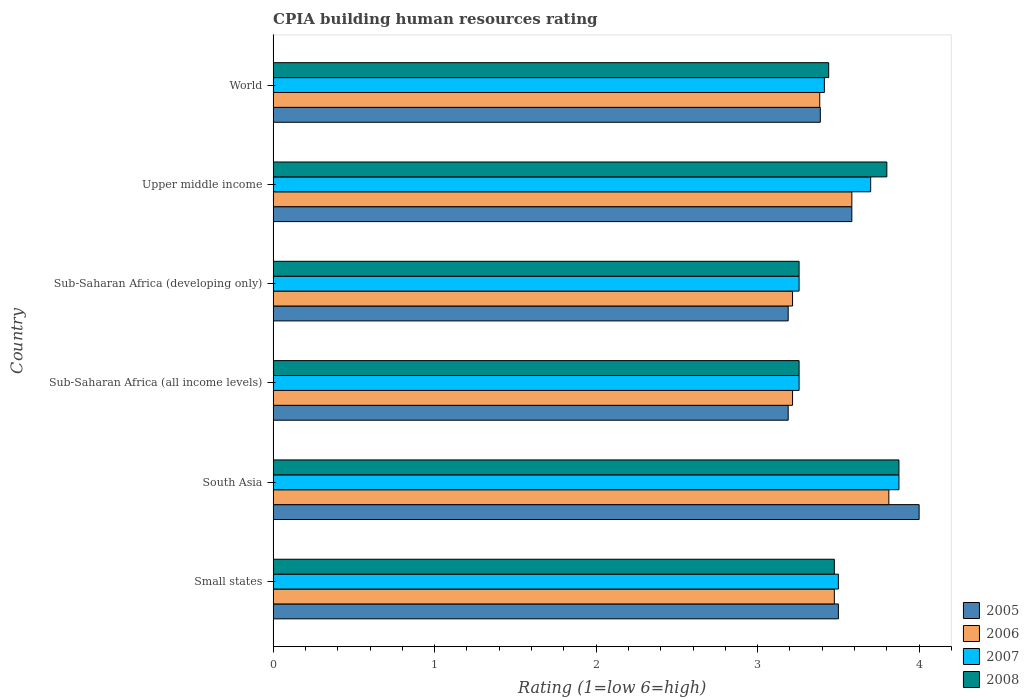How many groups of bars are there?
Your answer should be compact. 6. Are the number of bars per tick equal to the number of legend labels?
Your response must be concise. Yes. Are the number of bars on each tick of the Y-axis equal?
Provide a short and direct response. Yes. How many bars are there on the 6th tick from the bottom?
Your response must be concise. 4. What is the label of the 6th group of bars from the top?
Give a very brief answer. Small states. In how many cases, is the number of bars for a given country not equal to the number of legend labels?
Keep it short and to the point. 0. What is the CPIA rating in 2007 in World?
Keep it short and to the point. 3.41. Across all countries, what is the maximum CPIA rating in 2005?
Provide a short and direct response. 4. Across all countries, what is the minimum CPIA rating in 2005?
Ensure brevity in your answer.  3.19. In which country was the CPIA rating in 2008 maximum?
Offer a terse response. South Asia. In which country was the CPIA rating in 2006 minimum?
Ensure brevity in your answer.  Sub-Saharan Africa (all income levels). What is the total CPIA rating in 2005 in the graph?
Give a very brief answer. 20.85. What is the difference between the CPIA rating in 2005 in Small states and that in World?
Provide a short and direct response. 0.11. What is the difference between the CPIA rating in 2007 in Small states and the CPIA rating in 2008 in Upper middle income?
Your answer should be compact. -0.3. What is the average CPIA rating in 2008 per country?
Offer a terse response. 3.52. What is the difference between the CPIA rating in 2007 and CPIA rating in 2006 in Small states?
Ensure brevity in your answer.  0.02. What is the ratio of the CPIA rating in 2005 in South Asia to that in Sub-Saharan Africa (developing only)?
Provide a succinct answer. 1.25. Is the CPIA rating in 2006 in Small states less than that in Sub-Saharan Africa (all income levels)?
Give a very brief answer. No. Is the difference between the CPIA rating in 2007 in Sub-Saharan Africa (all income levels) and Sub-Saharan Africa (developing only) greater than the difference between the CPIA rating in 2006 in Sub-Saharan Africa (all income levels) and Sub-Saharan Africa (developing only)?
Your answer should be very brief. No. What is the difference between the highest and the second highest CPIA rating in 2006?
Provide a succinct answer. 0.23. What is the difference between the highest and the lowest CPIA rating in 2006?
Your answer should be compact. 0.6. In how many countries, is the CPIA rating in 2007 greater than the average CPIA rating in 2007 taken over all countries?
Your answer should be very brief. 2. Is the sum of the CPIA rating in 2007 in Upper middle income and World greater than the maximum CPIA rating in 2005 across all countries?
Keep it short and to the point. Yes. Is it the case that in every country, the sum of the CPIA rating in 2008 and CPIA rating in 2005 is greater than the sum of CPIA rating in 2007 and CPIA rating in 2006?
Your response must be concise. Yes. What does the 2nd bar from the top in Sub-Saharan Africa (developing only) represents?
Keep it short and to the point. 2007. Are all the bars in the graph horizontal?
Keep it short and to the point. Yes. How many countries are there in the graph?
Ensure brevity in your answer.  6. What is the difference between two consecutive major ticks on the X-axis?
Offer a very short reply. 1. Does the graph contain grids?
Your answer should be compact. No. How are the legend labels stacked?
Give a very brief answer. Vertical. What is the title of the graph?
Ensure brevity in your answer.  CPIA building human resources rating. What is the label or title of the X-axis?
Offer a terse response. Rating (1=low 6=high). What is the label or title of the Y-axis?
Provide a succinct answer. Country. What is the Rating (1=low 6=high) of 2006 in Small states?
Your response must be concise. 3.48. What is the Rating (1=low 6=high) of 2007 in Small states?
Provide a short and direct response. 3.5. What is the Rating (1=low 6=high) of 2008 in Small states?
Offer a very short reply. 3.48. What is the Rating (1=low 6=high) of 2005 in South Asia?
Offer a terse response. 4. What is the Rating (1=low 6=high) of 2006 in South Asia?
Your response must be concise. 3.81. What is the Rating (1=low 6=high) in 2007 in South Asia?
Your answer should be compact. 3.88. What is the Rating (1=low 6=high) of 2008 in South Asia?
Make the answer very short. 3.88. What is the Rating (1=low 6=high) of 2005 in Sub-Saharan Africa (all income levels)?
Offer a terse response. 3.19. What is the Rating (1=low 6=high) in 2006 in Sub-Saharan Africa (all income levels)?
Your response must be concise. 3.22. What is the Rating (1=low 6=high) of 2007 in Sub-Saharan Africa (all income levels)?
Ensure brevity in your answer.  3.26. What is the Rating (1=low 6=high) in 2008 in Sub-Saharan Africa (all income levels)?
Your response must be concise. 3.26. What is the Rating (1=low 6=high) in 2005 in Sub-Saharan Africa (developing only)?
Your answer should be compact. 3.19. What is the Rating (1=low 6=high) of 2006 in Sub-Saharan Africa (developing only)?
Give a very brief answer. 3.22. What is the Rating (1=low 6=high) in 2007 in Sub-Saharan Africa (developing only)?
Ensure brevity in your answer.  3.26. What is the Rating (1=low 6=high) of 2008 in Sub-Saharan Africa (developing only)?
Offer a terse response. 3.26. What is the Rating (1=low 6=high) in 2005 in Upper middle income?
Your answer should be very brief. 3.58. What is the Rating (1=low 6=high) in 2006 in Upper middle income?
Provide a short and direct response. 3.58. What is the Rating (1=low 6=high) of 2005 in World?
Ensure brevity in your answer.  3.39. What is the Rating (1=low 6=high) of 2006 in World?
Provide a short and direct response. 3.38. What is the Rating (1=low 6=high) in 2007 in World?
Provide a succinct answer. 3.41. What is the Rating (1=low 6=high) of 2008 in World?
Keep it short and to the point. 3.44. Across all countries, what is the maximum Rating (1=low 6=high) in 2005?
Your answer should be very brief. 4. Across all countries, what is the maximum Rating (1=low 6=high) in 2006?
Offer a very short reply. 3.81. Across all countries, what is the maximum Rating (1=low 6=high) in 2007?
Ensure brevity in your answer.  3.88. Across all countries, what is the maximum Rating (1=low 6=high) in 2008?
Ensure brevity in your answer.  3.88. Across all countries, what is the minimum Rating (1=low 6=high) of 2005?
Offer a terse response. 3.19. Across all countries, what is the minimum Rating (1=low 6=high) in 2006?
Your answer should be very brief. 3.22. Across all countries, what is the minimum Rating (1=low 6=high) in 2007?
Your answer should be compact. 3.26. Across all countries, what is the minimum Rating (1=low 6=high) of 2008?
Your answer should be very brief. 3.26. What is the total Rating (1=low 6=high) of 2005 in the graph?
Keep it short and to the point. 20.85. What is the total Rating (1=low 6=high) of 2006 in the graph?
Offer a very short reply. 20.69. What is the total Rating (1=low 6=high) in 2007 in the graph?
Make the answer very short. 21. What is the total Rating (1=low 6=high) of 2008 in the graph?
Offer a very short reply. 21.1. What is the difference between the Rating (1=low 6=high) of 2006 in Small states and that in South Asia?
Your answer should be compact. -0.34. What is the difference between the Rating (1=low 6=high) in 2007 in Small states and that in South Asia?
Offer a very short reply. -0.38. What is the difference between the Rating (1=low 6=high) of 2005 in Small states and that in Sub-Saharan Africa (all income levels)?
Provide a short and direct response. 0.31. What is the difference between the Rating (1=low 6=high) in 2006 in Small states and that in Sub-Saharan Africa (all income levels)?
Your answer should be very brief. 0.26. What is the difference between the Rating (1=low 6=high) in 2007 in Small states and that in Sub-Saharan Africa (all income levels)?
Ensure brevity in your answer.  0.24. What is the difference between the Rating (1=low 6=high) in 2008 in Small states and that in Sub-Saharan Africa (all income levels)?
Your answer should be compact. 0.22. What is the difference between the Rating (1=low 6=high) in 2005 in Small states and that in Sub-Saharan Africa (developing only)?
Offer a very short reply. 0.31. What is the difference between the Rating (1=low 6=high) in 2006 in Small states and that in Sub-Saharan Africa (developing only)?
Offer a very short reply. 0.26. What is the difference between the Rating (1=low 6=high) of 2007 in Small states and that in Sub-Saharan Africa (developing only)?
Your response must be concise. 0.24. What is the difference between the Rating (1=low 6=high) of 2008 in Small states and that in Sub-Saharan Africa (developing only)?
Offer a terse response. 0.22. What is the difference between the Rating (1=low 6=high) in 2005 in Small states and that in Upper middle income?
Your answer should be very brief. -0.08. What is the difference between the Rating (1=low 6=high) of 2006 in Small states and that in Upper middle income?
Offer a very short reply. -0.11. What is the difference between the Rating (1=low 6=high) of 2008 in Small states and that in Upper middle income?
Offer a terse response. -0.33. What is the difference between the Rating (1=low 6=high) of 2005 in Small states and that in World?
Your response must be concise. 0.11. What is the difference between the Rating (1=low 6=high) of 2006 in Small states and that in World?
Provide a succinct answer. 0.09. What is the difference between the Rating (1=low 6=high) in 2007 in Small states and that in World?
Ensure brevity in your answer.  0.09. What is the difference between the Rating (1=low 6=high) in 2008 in Small states and that in World?
Offer a very short reply. 0.04. What is the difference between the Rating (1=low 6=high) of 2005 in South Asia and that in Sub-Saharan Africa (all income levels)?
Keep it short and to the point. 0.81. What is the difference between the Rating (1=low 6=high) of 2006 in South Asia and that in Sub-Saharan Africa (all income levels)?
Give a very brief answer. 0.6. What is the difference between the Rating (1=low 6=high) in 2007 in South Asia and that in Sub-Saharan Africa (all income levels)?
Your answer should be compact. 0.62. What is the difference between the Rating (1=low 6=high) of 2008 in South Asia and that in Sub-Saharan Africa (all income levels)?
Keep it short and to the point. 0.62. What is the difference between the Rating (1=low 6=high) in 2005 in South Asia and that in Sub-Saharan Africa (developing only)?
Your response must be concise. 0.81. What is the difference between the Rating (1=low 6=high) in 2006 in South Asia and that in Sub-Saharan Africa (developing only)?
Your response must be concise. 0.6. What is the difference between the Rating (1=low 6=high) of 2007 in South Asia and that in Sub-Saharan Africa (developing only)?
Provide a succinct answer. 0.62. What is the difference between the Rating (1=low 6=high) in 2008 in South Asia and that in Sub-Saharan Africa (developing only)?
Make the answer very short. 0.62. What is the difference between the Rating (1=low 6=high) in 2005 in South Asia and that in Upper middle income?
Your answer should be compact. 0.42. What is the difference between the Rating (1=low 6=high) of 2006 in South Asia and that in Upper middle income?
Ensure brevity in your answer.  0.23. What is the difference between the Rating (1=low 6=high) of 2007 in South Asia and that in Upper middle income?
Keep it short and to the point. 0.17. What is the difference between the Rating (1=low 6=high) of 2008 in South Asia and that in Upper middle income?
Make the answer very short. 0.07. What is the difference between the Rating (1=low 6=high) of 2005 in South Asia and that in World?
Offer a terse response. 0.61. What is the difference between the Rating (1=low 6=high) of 2006 in South Asia and that in World?
Provide a short and direct response. 0.43. What is the difference between the Rating (1=low 6=high) in 2007 in South Asia and that in World?
Your response must be concise. 0.46. What is the difference between the Rating (1=low 6=high) of 2008 in South Asia and that in World?
Your answer should be compact. 0.43. What is the difference between the Rating (1=low 6=high) in 2005 in Sub-Saharan Africa (all income levels) and that in Sub-Saharan Africa (developing only)?
Provide a succinct answer. 0. What is the difference between the Rating (1=low 6=high) of 2006 in Sub-Saharan Africa (all income levels) and that in Sub-Saharan Africa (developing only)?
Provide a short and direct response. 0. What is the difference between the Rating (1=low 6=high) in 2007 in Sub-Saharan Africa (all income levels) and that in Sub-Saharan Africa (developing only)?
Your response must be concise. 0. What is the difference between the Rating (1=low 6=high) in 2005 in Sub-Saharan Africa (all income levels) and that in Upper middle income?
Give a very brief answer. -0.39. What is the difference between the Rating (1=low 6=high) in 2006 in Sub-Saharan Africa (all income levels) and that in Upper middle income?
Ensure brevity in your answer.  -0.37. What is the difference between the Rating (1=low 6=high) in 2007 in Sub-Saharan Africa (all income levels) and that in Upper middle income?
Give a very brief answer. -0.44. What is the difference between the Rating (1=low 6=high) of 2008 in Sub-Saharan Africa (all income levels) and that in Upper middle income?
Offer a terse response. -0.54. What is the difference between the Rating (1=low 6=high) of 2005 in Sub-Saharan Africa (all income levels) and that in World?
Provide a succinct answer. -0.2. What is the difference between the Rating (1=low 6=high) of 2006 in Sub-Saharan Africa (all income levels) and that in World?
Provide a short and direct response. -0.17. What is the difference between the Rating (1=low 6=high) of 2007 in Sub-Saharan Africa (all income levels) and that in World?
Your answer should be compact. -0.16. What is the difference between the Rating (1=low 6=high) in 2008 in Sub-Saharan Africa (all income levels) and that in World?
Give a very brief answer. -0.18. What is the difference between the Rating (1=low 6=high) of 2005 in Sub-Saharan Africa (developing only) and that in Upper middle income?
Offer a terse response. -0.39. What is the difference between the Rating (1=low 6=high) of 2006 in Sub-Saharan Africa (developing only) and that in Upper middle income?
Your answer should be compact. -0.37. What is the difference between the Rating (1=low 6=high) in 2007 in Sub-Saharan Africa (developing only) and that in Upper middle income?
Provide a short and direct response. -0.44. What is the difference between the Rating (1=low 6=high) in 2008 in Sub-Saharan Africa (developing only) and that in Upper middle income?
Your answer should be very brief. -0.54. What is the difference between the Rating (1=low 6=high) in 2005 in Sub-Saharan Africa (developing only) and that in World?
Provide a short and direct response. -0.2. What is the difference between the Rating (1=low 6=high) of 2006 in Sub-Saharan Africa (developing only) and that in World?
Your response must be concise. -0.17. What is the difference between the Rating (1=low 6=high) of 2007 in Sub-Saharan Africa (developing only) and that in World?
Offer a terse response. -0.16. What is the difference between the Rating (1=low 6=high) of 2008 in Sub-Saharan Africa (developing only) and that in World?
Ensure brevity in your answer.  -0.18. What is the difference between the Rating (1=low 6=high) in 2005 in Upper middle income and that in World?
Give a very brief answer. 0.2. What is the difference between the Rating (1=low 6=high) in 2006 in Upper middle income and that in World?
Make the answer very short. 0.2. What is the difference between the Rating (1=low 6=high) of 2007 in Upper middle income and that in World?
Offer a very short reply. 0.29. What is the difference between the Rating (1=low 6=high) in 2008 in Upper middle income and that in World?
Ensure brevity in your answer.  0.36. What is the difference between the Rating (1=low 6=high) of 2005 in Small states and the Rating (1=low 6=high) of 2006 in South Asia?
Offer a terse response. -0.31. What is the difference between the Rating (1=low 6=high) in 2005 in Small states and the Rating (1=low 6=high) in 2007 in South Asia?
Offer a terse response. -0.38. What is the difference between the Rating (1=low 6=high) in 2005 in Small states and the Rating (1=low 6=high) in 2008 in South Asia?
Ensure brevity in your answer.  -0.38. What is the difference between the Rating (1=low 6=high) of 2006 in Small states and the Rating (1=low 6=high) of 2007 in South Asia?
Offer a very short reply. -0.4. What is the difference between the Rating (1=low 6=high) of 2006 in Small states and the Rating (1=low 6=high) of 2008 in South Asia?
Provide a short and direct response. -0.4. What is the difference between the Rating (1=low 6=high) in 2007 in Small states and the Rating (1=low 6=high) in 2008 in South Asia?
Keep it short and to the point. -0.38. What is the difference between the Rating (1=low 6=high) in 2005 in Small states and the Rating (1=low 6=high) in 2006 in Sub-Saharan Africa (all income levels)?
Keep it short and to the point. 0.28. What is the difference between the Rating (1=low 6=high) of 2005 in Small states and the Rating (1=low 6=high) of 2007 in Sub-Saharan Africa (all income levels)?
Give a very brief answer. 0.24. What is the difference between the Rating (1=low 6=high) in 2005 in Small states and the Rating (1=low 6=high) in 2008 in Sub-Saharan Africa (all income levels)?
Give a very brief answer. 0.24. What is the difference between the Rating (1=low 6=high) of 2006 in Small states and the Rating (1=low 6=high) of 2007 in Sub-Saharan Africa (all income levels)?
Give a very brief answer. 0.22. What is the difference between the Rating (1=low 6=high) of 2006 in Small states and the Rating (1=low 6=high) of 2008 in Sub-Saharan Africa (all income levels)?
Ensure brevity in your answer.  0.22. What is the difference between the Rating (1=low 6=high) in 2007 in Small states and the Rating (1=low 6=high) in 2008 in Sub-Saharan Africa (all income levels)?
Give a very brief answer. 0.24. What is the difference between the Rating (1=low 6=high) of 2005 in Small states and the Rating (1=low 6=high) of 2006 in Sub-Saharan Africa (developing only)?
Make the answer very short. 0.28. What is the difference between the Rating (1=low 6=high) of 2005 in Small states and the Rating (1=low 6=high) of 2007 in Sub-Saharan Africa (developing only)?
Provide a short and direct response. 0.24. What is the difference between the Rating (1=low 6=high) in 2005 in Small states and the Rating (1=low 6=high) in 2008 in Sub-Saharan Africa (developing only)?
Your answer should be very brief. 0.24. What is the difference between the Rating (1=low 6=high) in 2006 in Small states and the Rating (1=low 6=high) in 2007 in Sub-Saharan Africa (developing only)?
Give a very brief answer. 0.22. What is the difference between the Rating (1=low 6=high) of 2006 in Small states and the Rating (1=low 6=high) of 2008 in Sub-Saharan Africa (developing only)?
Give a very brief answer. 0.22. What is the difference between the Rating (1=low 6=high) of 2007 in Small states and the Rating (1=low 6=high) of 2008 in Sub-Saharan Africa (developing only)?
Provide a succinct answer. 0.24. What is the difference between the Rating (1=low 6=high) in 2005 in Small states and the Rating (1=low 6=high) in 2006 in Upper middle income?
Make the answer very short. -0.08. What is the difference between the Rating (1=low 6=high) in 2005 in Small states and the Rating (1=low 6=high) in 2007 in Upper middle income?
Ensure brevity in your answer.  -0.2. What is the difference between the Rating (1=low 6=high) in 2005 in Small states and the Rating (1=low 6=high) in 2008 in Upper middle income?
Provide a succinct answer. -0.3. What is the difference between the Rating (1=low 6=high) of 2006 in Small states and the Rating (1=low 6=high) of 2007 in Upper middle income?
Make the answer very short. -0.23. What is the difference between the Rating (1=low 6=high) of 2006 in Small states and the Rating (1=low 6=high) of 2008 in Upper middle income?
Your answer should be very brief. -0.33. What is the difference between the Rating (1=low 6=high) in 2007 in Small states and the Rating (1=low 6=high) in 2008 in Upper middle income?
Your answer should be very brief. -0.3. What is the difference between the Rating (1=low 6=high) of 2005 in Small states and the Rating (1=low 6=high) of 2006 in World?
Your response must be concise. 0.12. What is the difference between the Rating (1=low 6=high) in 2005 in Small states and the Rating (1=low 6=high) in 2007 in World?
Ensure brevity in your answer.  0.09. What is the difference between the Rating (1=low 6=high) of 2006 in Small states and the Rating (1=low 6=high) of 2007 in World?
Offer a terse response. 0.06. What is the difference between the Rating (1=low 6=high) in 2006 in Small states and the Rating (1=low 6=high) in 2008 in World?
Provide a short and direct response. 0.04. What is the difference between the Rating (1=low 6=high) in 2007 in Small states and the Rating (1=low 6=high) in 2008 in World?
Keep it short and to the point. 0.06. What is the difference between the Rating (1=low 6=high) in 2005 in South Asia and the Rating (1=low 6=high) in 2006 in Sub-Saharan Africa (all income levels)?
Your answer should be compact. 0.78. What is the difference between the Rating (1=low 6=high) in 2005 in South Asia and the Rating (1=low 6=high) in 2007 in Sub-Saharan Africa (all income levels)?
Make the answer very short. 0.74. What is the difference between the Rating (1=low 6=high) in 2005 in South Asia and the Rating (1=low 6=high) in 2008 in Sub-Saharan Africa (all income levels)?
Keep it short and to the point. 0.74. What is the difference between the Rating (1=low 6=high) in 2006 in South Asia and the Rating (1=low 6=high) in 2007 in Sub-Saharan Africa (all income levels)?
Make the answer very short. 0.56. What is the difference between the Rating (1=low 6=high) of 2006 in South Asia and the Rating (1=low 6=high) of 2008 in Sub-Saharan Africa (all income levels)?
Keep it short and to the point. 0.56. What is the difference between the Rating (1=low 6=high) of 2007 in South Asia and the Rating (1=low 6=high) of 2008 in Sub-Saharan Africa (all income levels)?
Provide a short and direct response. 0.62. What is the difference between the Rating (1=low 6=high) of 2005 in South Asia and the Rating (1=low 6=high) of 2006 in Sub-Saharan Africa (developing only)?
Provide a succinct answer. 0.78. What is the difference between the Rating (1=low 6=high) in 2005 in South Asia and the Rating (1=low 6=high) in 2007 in Sub-Saharan Africa (developing only)?
Offer a terse response. 0.74. What is the difference between the Rating (1=low 6=high) of 2005 in South Asia and the Rating (1=low 6=high) of 2008 in Sub-Saharan Africa (developing only)?
Provide a succinct answer. 0.74. What is the difference between the Rating (1=low 6=high) in 2006 in South Asia and the Rating (1=low 6=high) in 2007 in Sub-Saharan Africa (developing only)?
Provide a succinct answer. 0.56. What is the difference between the Rating (1=low 6=high) of 2006 in South Asia and the Rating (1=low 6=high) of 2008 in Sub-Saharan Africa (developing only)?
Your answer should be very brief. 0.56. What is the difference between the Rating (1=low 6=high) of 2007 in South Asia and the Rating (1=low 6=high) of 2008 in Sub-Saharan Africa (developing only)?
Offer a terse response. 0.62. What is the difference between the Rating (1=low 6=high) of 2005 in South Asia and the Rating (1=low 6=high) of 2006 in Upper middle income?
Provide a short and direct response. 0.42. What is the difference between the Rating (1=low 6=high) in 2005 in South Asia and the Rating (1=low 6=high) in 2007 in Upper middle income?
Your response must be concise. 0.3. What is the difference between the Rating (1=low 6=high) of 2005 in South Asia and the Rating (1=low 6=high) of 2008 in Upper middle income?
Provide a succinct answer. 0.2. What is the difference between the Rating (1=low 6=high) of 2006 in South Asia and the Rating (1=low 6=high) of 2007 in Upper middle income?
Ensure brevity in your answer.  0.11. What is the difference between the Rating (1=low 6=high) of 2006 in South Asia and the Rating (1=low 6=high) of 2008 in Upper middle income?
Give a very brief answer. 0.01. What is the difference between the Rating (1=low 6=high) of 2007 in South Asia and the Rating (1=low 6=high) of 2008 in Upper middle income?
Provide a succinct answer. 0.07. What is the difference between the Rating (1=low 6=high) of 2005 in South Asia and the Rating (1=low 6=high) of 2006 in World?
Your answer should be very brief. 0.62. What is the difference between the Rating (1=low 6=high) in 2005 in South Asia and the Rating (1=low 6=high) in 2007 in World?
Ensure brevity in your answer.  0.59. What is the difference between the Rating (1=low 6=high) in 2005 in South Asia and the Rating (1=low 6=high) in 2008 in World?
Provide a short and direct response. 0.56. What is the difference between the Rating (1=low 6=high) in 2006 in South Asia and the Rating (1=low 6=high) in 2007 in World?
Your answer should be very brief. 0.4. What is the difference between the Rating (1=low 6=high) in 2006 in South Asia and the Rating (1=low 6=high) in 2008 in World?
Your answer should be compact. 0.37. What is the difference between the Rating (1=low 6=high) in 2007 in South Asia and the Rating (1=low 6=high) in 2008 in World?
Provide a short and direct response. 0.43. What is the difference between the Rating (1=low 6=high) of 2005 in Sub-Saharan Africa (all income levels) and the Rating (1=low 6=high) of 2006 in Sub-Saharan Africa (developing only)?
Offer a terse response. -0.03. What is the difference between the Rating (1=low 6=high) of 2005 in Sub-Saharan Africa (all income levels) and the Rating (1=low 6=high) of 2007 in Sub-Saharan Africa (developing only)?
Provide a succinct answer. -0.07. What is the difference between the Rating (1=low 6=high) of 2005 in Sub-Saharan Africa (all income levels) and the Rating (1=low 6=high) of 2008 in Sub-Saharan Africa (developing only)?
Keep it short and to the point. -0.07. What is the difference between the Rating (1=low 6=high) in 2006 in Sub-Saharan Africa (all income levels) and the Rating (1=low 6=high) in 2007 in Sub-Saharan Africa (developing only)?
Provide a short and direct response. -0.04. What is the difference between the Rating (1=low 6=high) of 2006 in Sub-Saharan Africa (all income levels) and the Rating (1=low 6=high) of 2008 in Sub-Saharan Africa (developing only)?
Ensure brevity in your answer.  -0.04. What is the difference between the Rating (1=low 6=high) of 2005 in Sub-Saharan Africa (all income levels) and the Rating (1=low 6=high) of 2006 in Upper middle income?
Your answer should be compact. -0.39. What is the difference between the Rating (1=low 6=high) in 2005 in Sub-Saharan Africa (all income levels) and the Rating (1=low 6=high) in 2007 in Upper middle income?
Provide a succinct answer. -0.51. What is the difference between the Rating (1=low 6=high) of 2005 in Sub-Saharan Africa (all income levels) and the Rating (1=low 6=high) of 2008 in Upper middle income?
Provide a short and direct response. -0.61. What is the difference between the Rating (1=low 6=high) of 2006 in Sub-Saharan Africa (all income levels) and the Rating (1=low 6=high) of 2007 in Upper middle income?
Ensure brevity in your answer.  -0.48. What is the difference between the Rating (1=low 6=high) in 2006 in Sub-Saharan Africa (all income levels) and the Rating (1=low 6=high) in 2008 in Upper middle income?
Offer a terse response. -0.58. What is the difference between the Rating (1=low 6=high) of 2007 in Sub-Saharan Africa (all income levels) and the Rating (1=low 6=high) of 2008 in Upper middle income?
Give a very brief answer. -0.54. What is the difference between the Rating (1=low 6=high) in 2005 in Sub-Saharan Africa (all income levels) and the Rating (1=low 6=high) in 2006 in World?
Offer a very short reply. -0.2. What is the difference between the Rating (1=low 6=high) in 2005 in Sub-Saharan Africa (all income levels) and the Rating (1=low 6=high) in 2007 in World?
Give a very brief answer. -0.22. What is the difference between the Rating (1=low 6=high) of 2005 in Sub-Saharan Africa (all income levels) and the Rating (1=low 6=high) of 2008 in World?
Keep it short and to the point. -0.25. What is the difference between the Rating (1=low 6=high) of 2006 in Sub-Saharan Africa (all income levels) and the Rating (1=low 6=high) of 2007 in World?
Keep it short and to the point. -0.2. What is the difference between the Rating (1=low 6=high) of 2006 in Sub-Saharan Africa (all income levels) and the Rating (1=low 6=high) of 2008 in World?
Your answer should be very brief. -0.22. What is the difference between the Rating (1=low 6=high) of 2007 in Sub-Saharan Africa (all income levels) and the Rating (1=low 6=high) of 2008 in World?
Offer a very short reply. -0.18. What is the difference between the Rating (1=low 6=high) in 2005 in Sub-Saharan Africa (developing only) and the Rating (1=low 6=high) in 2006 in Upper middle income?
Provide a short and direct response. -0.39. What is the difference between the Rating (1=low 6=high) of 2005 in Sub-Saharan Africa (developing only) and the Rating (1=low 6=high) of 2007 in Upper middle income?
Keep it short and to the point. -0.51. What is the difference between the Rating (1=low 6=high) in 2005 in Sub-Saharan Africa (developing only) and the Rating (1=low 6=high) in 2008 in Upper middle income?
Ensure brevity in your answer.  -0.61. What is the difference between the Rating (1=low 6=high) in 2006 in Sub-Saharan Africa (developing only) and the Rating (1=low 6=high) in 2007 in Upper middle income?
Offer a very short reply. -0.48. What is the difference between the Rating (1=low 6=high) in 2006 in Sub-Saharan Africa (developing only) and the Rating (1=low 6=high) in 2008 in Upper middle income?
Provide a succinct answer. -0.58. What is the difference between the Rating (1=low 6=high) in 2007 in Sub-Saharan Africa (developing only) and the Rating (1=low 6=high) in 2008 in Upper middle income?
Offer a terse response. -0.54. What is the difference between the Rating (1=low 6=high) of 2005 in Sub-Saharan Africa (developing only) and the Rating (1=low 6=high) of 2006 in World?
Your response must be concise. -0.2. What is the difference between the Rating (1=low 6=high) of 2005 in Sub-Saharan Africa (developing only) and the Rating (1=low 6=high) of 2007 in World?
Provide a succinct answer. -0.22. What is the difference between the Rating (1=low 6=high) of 2005 in Sub-Saharan Africa (developing only) and the Rating (1=low 6=high) of 2008 in World?
Your answer should be very brief. -0.25. What is the difference between the Rating (1=low 6=high) of 2006 in Sub-Saharan Africa (developing only) and the Rating (1=low 6=high) of 2007 in World?
Your answer should be compact. -0.2. What is the difference between the Rating (1=low 6=high) in 2006 in Sub-Saharan Africa (developing only) and the Rating (1=low 6=high) in 2008 in World?
Provide a short and direct response. -0.22. What is the difference between the Rating (1=low 6=high) in 2007 in Sub-Saharan Africa (developing only) and the Rating (1=low 6=high) in 2008 in World?
Give a very brief answer. -0.18. What is the difference between the Rating (1=low 6=high) in 2005 in Upper middle income and the Rating (1=low 6=high) in 2006 in World?
Make the answer very short. 0.2. What is the difference between the Rating (1=low 6=high) in 2005 in Upper middle income and the Rating (1=low 6=high) in 2007 in World?
Your answer should be compact. 0.17. What is the difference between the Rating (1=low 6=high) of 2005 in Upper middle income and the Rating (1=low 6=high) of 2008 in World?
Your answer should be very brief. 0.14. What is the difference between the Rating (1=low 6=high) in 2006 in Upper middle income and the Rating (1=low 6=high) in 2007 in World?
Provide a short and direct response. 0.17. What is the difference between the Rating (1=low 6=high) of 2006 in Upper middle income and the Rating (1=low 6=high) of 2008 in World?
Provide a short and direct response. 0.14. What is the difference between the Rating (1=low 6=high) in 2007 in Upper middle income and the Rating (1=low 6=high) in 2008 in World?
Provide a short and direct response. 0.26. What is the average Rating (1=low 6=high) of 2005 per country?
Your answer should be compact. 3.48. What is the average Rating (1=low 6=high) in 2006 per country?
Provide a short and direct response. 3.45. What is the average Rating (1=low 6=high) of 2007 per country?
Provide a short and direct response. 3.5. What is the average Rating (1=low 6=high) in 2008 per country?
Offer a very short reply. 3.52. What is the difference between the Rating (1=low 6=high) of 2005 and Rating (1=low 6=high) of 2006 in Small states?
Your response must be concise. 0.03. What is the difference between the Rating (1=low 6=high) in 2005 and Rating (1=low 6=high) in 2007 in Small states?
Your answer should be very brief. 0. What is the difference between the Rating (1=low 6=high) of 2005 and Rating (1=low 6=high) of 2008 in Small states?
Give a very brief answer. 0.03. What is the difference between the Rating (1=low 6=high) of 2006 and Rating (1=low 6=high) of 2007 in Small states?
Your answer should be very brief. -0.03. What is the difference between the Rating (1=low 6=high) of 2007 and Rating (1=low 6=high) of 2008 in Small states?
Your answer should be very brief. 0.03. What is the difference between the Rating (1=low 6=high) of 2005 and Rating (1=low 6=high) of 2006 in South Asia?
Give a very brief answer. 0.19. What is the difference between the Rating (1=low 6=high) in 2005 and Rating (1=low 6=high) in 2008 in South Asia?
Give a very brief answer. 0.12. What is the difference between the Rating (1=low 6=high) of 2006 and Rating (1=low 6=high) of 2007 in South Asia?
Your answer should be compact. -0.06. What is the difference between the Rating (1=low 6=high) of 2006 and Rating (1=low 6=high) of 2008 in South Asia?
Make the answer very short. -0.06. What is the difference between the Rating (1=low 6=high) in 2007 and Rating (1=low 6=high) in 2008 in South Asia?
Give a very brief answer. 0. What is the difference between the Rating (1=low 6=high) in 2005 and Rating (1=low 6=high) in 2006 in Sub-Saharan Africa (all income levels)?
Keep it short and to the point. -0.03. What is the difference between the Rating (1=low 6=high) in 2005 and Rating (1=low 6=high) in 2007 in Sub-Saharan Africa (all income levels)?
Make the answer very short. -0.07. What is the difference between the Rating (1=low 6=high) of 2005 and Rating (1=low 6=high) of 2008 in Sub-Saharan Africa (all income levels)?
Your answer should be compact. -0.07. What is the difference between the Rating (1=low 6=high) in 2006 and Rating (1=low 6=high) in 2007 in Sub-Saharan Africa (all income levels)?
Offer a very short reply. -0.04. What is the difference between the Rating (1=low 6=high) in 2006 and Rating (1=low 6=high) in 2008 in Sub-Saharan Africa (all income levels)?
Ensure brevity in your answer.  -0.04. What is the difference between the Rating (1=low 6=high) of 2007 and Rating (1=low 6=high) of 2008 in Sub-Saharan Africa (all income levels)?
Keep it short and to the point. 0. What is the difference between the Rating (1=low 6=high) of 2005 and Rating (1=low 6=high) of 2006 in Sub-Saharan Africa (developing only)?
Ensure brevity in your answer.  -0.03. What is the difference between the Rating (1=low 6=high) in 2005 and Rating (1=low 6=high) in 2007 in Sub-Saharan Africa (developing only)?
Provide a short and direct response. -0.07. What is the difference between the Rating (1=low 6=high) of 2005 and Rating (1=low 6=high) of 2008 in Sub-Saharan Africa (developing only)?
Offer a terse response. -0.07. What is the difference between the Rating (1=low 6=high) of 2006 and Rating (1=low 6=high) of 2007 in Sub-Saharan Africa (developing only)?
Give a very brief answer. -0.04. What is the difference between the Rating (1=low 6=high) of 2006 and Rating (1=low 6=high) of 2008 in Sub-Saharan Africa (developing only)?
Give a very brief answer. -0.04. What is the difference between the Rating (1=low 6=high) of 2007 and Rating (1=low 6=high) of 2008 in Sub-Saharan Africa (developing only)?
Offer a very short reply. 0. What is the difference between the Rating (1=low 6=high) in 2005 and Rating (1=low 6=high) in 2007 in Upper middle income?
Your response must be concise. -0.12. What is the difference between the Rating (1=low 6=high) of 2005 and Rating (1=low 6=high) of 2008 in Upper middle income?
Your answer should be compact. -0.22. What is the difference between the Rating (1=low 6=high) of 2006 and Rating (1=low 6=high) of 2007 in Upper middle income?
Ensure brevity in your answer.  -0.12. What is the difference between the Rating (1=low 6=high) of 2006 and Rating (1=low 6=high) of 2008 in Upper middle income?
Your response must be concise. -0.22. What is the difference between the Rating (1=low 6=high) of 2007 and Rating (1=low 6=high) of 2008 in Upper middle income?
Keep it short and to the point. -0.1. What is the difference between the Rating (1=low 6=high) in 2005 and Rating (1=low 6=high) in 2006 in World?
Provide a short and direct response. 0. What is the difference between the Rating (1=low 6=high) of 2005 and Rating (1=low 6=high) of 2007 in World?
Give a very brief answer. -0.03. What is the difference between the Rating (1=low 6=high) in 2005 and Rating (1=low 6=high) in 2008 in World?
Your response must be concise. -0.05. What is the difference between the Rating (1=low 6=high) of 2006 and Rating (1=low 6=high) of 2007 in World?
Provide a succinct answer. -0.03. What is the difference between the Rating (1=low 6=high) of 2006 and Rating (1=low 6=high) of 2008 in World?
Make the answer very short. -0.06. What is the difference between the Rating (1=low 6=high) in 2007 and Rating (1=low 6=high) in 2008 in World?
Your answer should be compact. -0.03. What is the ratio of the Rating (1=low 6=high) of 2005 in Small states to that in South Asia?
Keep it short and to the point. 0.88. What is the ratio of the Rating (1=low 6=high) in 2006 in Small states to that in South Asia?
Your answer should be very brief. 0.91. What is the ratio of the Rating (1=low 6=high) of 2007 in Small states to that in South Asia?
Provide a succinct answer. 0.9. What is the ratio of the Rating (1=low 6=high) of 2008 in Small states to that in South Asia?
Give a very brief answer. 0.9. What is the ratio of the Rating (1=low 6=high) in 2005 in Small states to that in Sub-Saharan Africa (all income levels)?
Your answer should be very brief. 1.1. What is the ratio of the Rating (1=low 6=high) of 2006 in Small states to that in Sub-Saharan Africa (all income levels)?
Make the answer very short. 1.08. What is the ratio of the Rating (1=low 6=high) of 2007 in Small states to that in Sub-Saharan Africa (all income levels)?
Provide a succinct answer. 1.07. What is the ratio of the Rating (1=low 6=high) in 2008 in Small states to that in Sub-Saharan Africa (all income levels)?
Keep it short and to the point. 1.07. What is the ratio of the Rating (1=low 6=high) of 2005 in Small states to that in Sub-Saharan Africa (developing only)?
Offer a terse response. 1.1. What is the ratio of the Rating (1=low 6=high) in 2006 in Small states to that in Sub-Saharan Africa (developing only)?
Keep it short and to the point. 1.08. What is the ratio of the Rating (1=low 6=high) in 2007 in Small states to that in Sub-Saharan Africa (developing only)?
Keep it short and to the point. 1.07. What is the ratio of the Rating (1=low 6=high) in 2008 in Small states to that in Sub-Saharan Africa (developing only)?
Make the answer very short. 1.07. What is the ratio of the Rating (1=low 6=high) in 2005 in Small states to that in Upper middle income?
Provide a short and direct response. 0.98. What is the ratio of the Rating (1=low 6=high) of 2006 in Small states to that in Upper middle income?
Provide a succinct answer. 0.97. What is the ratio of the Rating (1=low 6=high) of 2007 in Small states to that in Upper middle income?
Give a very brief answer. 0.95. What is the ratio of the Rating (1=low 6=high) of 2008 in Small states to that in Upper middle income?
Provide a succinct answer. 0.91. What is the ratio of the Rating (1=low 6=high) in 2005 in Small states to that in World?
Give a very brief answer. 1.03. What is the ratio of the Rating (1=low 6=high) in 2006 in Small states to that in World?
Keep it short and to the point. 1.03. What is the ratio of the Rating (1=low 6=high) of 2007 in Small states to that in World?
Your answer should be very brief. 1.03. What is the ratio of the Rating (1=low 6=high) in 2008 in Small states to that in World?
Make the answer very short. 1.01. What is the ratio of the Rating (1=low 6=high) in 2005 in South Asia to that in Sub-Saharan Africa (all income levels)?
Provide a succinct answer. 1.25. What is the ratio of the Rating (1=low 6=high) in 2006 in South Asia to that in Sub-Saharan Africa (all income levels)?
Your answer should be very brief. 1.19. What is the ratio of the Rating (1=low 6=high) in 2007 in South Asia to that in Sub-Saharan Africa (all income levels)?
Make the answer very short. 1.19. What is the ratio of the Rating (1=low 6=high) of 2008 in South Asia to that in Sub-Saharan Africa (all income levels)?
Provide a short and direct response. 1.19. What is the ratio of the Rating (1=low 6=high) in 2005 in South Asia to that in Sub-Saharan Africa (developing only)?
Offer a very short reply. 1.25. What is the ratio of the Rating (1=low 6=high) of 2006 in South Asia to that in Sub-Saharan Africa (developing only)?
Your response must be concise. 1.19. What is the ratio of the Rating (1=low 6=high) of 2007 in South Asia to that in Sub-Saharan Africa (developing only)?
Provide a succinct answer. 1.19. What is the ratio of the Rating (1=low 6=high) of 2008 in South Asia to that in Sub-Saharan Africa (developing only)?
Provide a short and direct response. 1.19. What is the ratio of the Rating (1=low 6=high) in 2005 in South Asia to that in Upper middle income?
Offer a terse response. 1.12. What is the ratio of the Rating (1=low 6=high) in 2006 in South Asia to that in Upper middle income?
Your answer should be compact. 1.06. What is the ratio of the Rating (1=low 6=high) of 2007 in South Asia to that in Upper middle income?
Provide a short and direct response. 1.05. What is the ratio of the Rating (1=low 6=high) of 2008 in South Asia to that in Upper middle income?
Provide a short and direct response. 1.02. What is the ratio of the Rating (1=low 6=high) in 2005 in South Asia to that in World?
Offer a very short reply. 1.18. What is the ratio of the Rating (1=low 6=high) in 2006 in South Asia to that in World?
Ensure brevity in your answer.  1.13. What is the ratio of the Rating (1=low 6=high) of 2007 in South Asia to that in World?
Ensure brevity in your answer.  1.14. What is the ratio of the Rating (1=low 6=high) in 2008 in South Asia to that in World?
Ensure brevity in your answer.  1.13. What is the ratio of the Rating (1=low 6=high) in 2005 in Sub-Saharan Africa (all income levels) to that in Upper middle income?
Ensure brevity in your answer.  0.89. What is the ratio of the Rating (1=low 6=high) in 2006 in Sub-Saharan Africa (all income levels) to that in Upper middle income?
Your response must be concise. 0.9. What is the ratio of the Rating (1=low 6=high) in 2007 in Sub-Saharan Africa (all income levels) to that in Upper middle income?
Give a very brief answer. 0.88. What is the ratio of the Rating (1=low 6=high) in 2008 in Sub-Saharan Africa (all income levels) to that in Upper middle income?
Offer a very short reply. 0.86. What is the ratio of the Rating (1=low 6=high) in 2005 in Sub-Saharan Africa (all income levels) to that in World?
Make the answer very short. 0.94. What is the ratio of the Rating (1=low 6=high) of 2006 in Sub-Saharan Africa (all income levels) to that in World?
Offer a very short reply. 0.95. What is the ratio of the Rating (1=low 6=high) in 2007 in Sub-Saharan Africa (all income levels) to that in World?
Offer a very short reply. 0.95. What is the ratio of the Rating (1=low 6=high) of 2008 in Sub-Saharan Africa (all income levels) to that in World?
Offer a very short reply. 0.95. What is the ratio of the Rating (1=low 6=high) of 2005 in Sub-Saharan Africa (developing only) to that in Upper middle income?
Offer a very short reply. 0.89. What is the ratio of the Rating (1=low 6=high) in 2006 in Sub-Saharan Africa (developing only) to that in Upper middle income?
Keep it short and to the point. 0.9. What is the ratio of the Rating (1=low 6=high) in 2007 in Sub-Saharan Africa (developing only) to that in Upper middle income?
Make the answer very short. 0.88. What is the ratio of the Rating (1=low 6=high) in 2008 in Sub-Saharan Africa (developing only) to that in Upper middle income?
Your answer should be compact. 0.86. What is the ratio of the Rating (1=low 6=high) in 2005 in Sub-Saharan Africa (developing only) to that in World?
Provide a succinct answer. 0.94. What is the ratio of the Rating (1=low 6=high) in 2006 in Sub-Saharan Africa (developing only) to that in World?
Ensure brevity in your answer.  0.95. What is the ratio of the Rating (1=low 6=high) of 2007 in Sub-Saharan Africa (developing only) to that in World?
Make the answer very short. 0.95. What is the ratio of the Rating (1=low 6=high) of 2008 in Sub-Saharan Africa (developing only) to that in World?
Keep it short and to the point. 0.95. What is the ratio of the Rating (1=low 6=high) in 2005 in Upper middle income to that in World?
Your answer should be compact. 1.06. What is the ratio of the Rating (1=low 6=high) in 2006 in Upper middle income to that in World?
Your answer should be very brief. 1.06. What is the ratio of the Rating (1=low 6=high) in 2007 in Upper middle income to that in World?
Provide a succinct answer. 1.08. What is the ratio of the Rating (1=low 6=high) of 2008 in Upper middle income to that in World?
Give a very brief answer. 1.1. What is the difference between the highest and the second highest Rating (1=low 6=high) in 2005?
Your response must be concise. 0.42. What is the difference between the highest and the second highest Rating (1=low 6=high) in 2006?
Ensure brevity in your answer.  0.23. What is the difference between the highest and the second highest Rating (1=low 6=high) in 2007?
Provide a succinct answer. 0.17. What is the difference between the highest and the second highest Rating (1=low 6=high) of 2008?
Your response must be concise. 0.07. What is the difference between the highest and the lowest Rating (1=low 6=high) of 2005?
Ensure brevity in your answer.  0.81. What is the difference between the highest and the lowest Rating (1=low 6=high) of 2006?
Your answer should be compact. 0.6. What is the difference between the highest and the lowest Rating (1=low 6=high) of 2007?
Make the answer very short. 0.62. What is the difference between the highest and the lowest Rating (1=low 6=high) of 2008?
Your response must be concise. 0.62. 